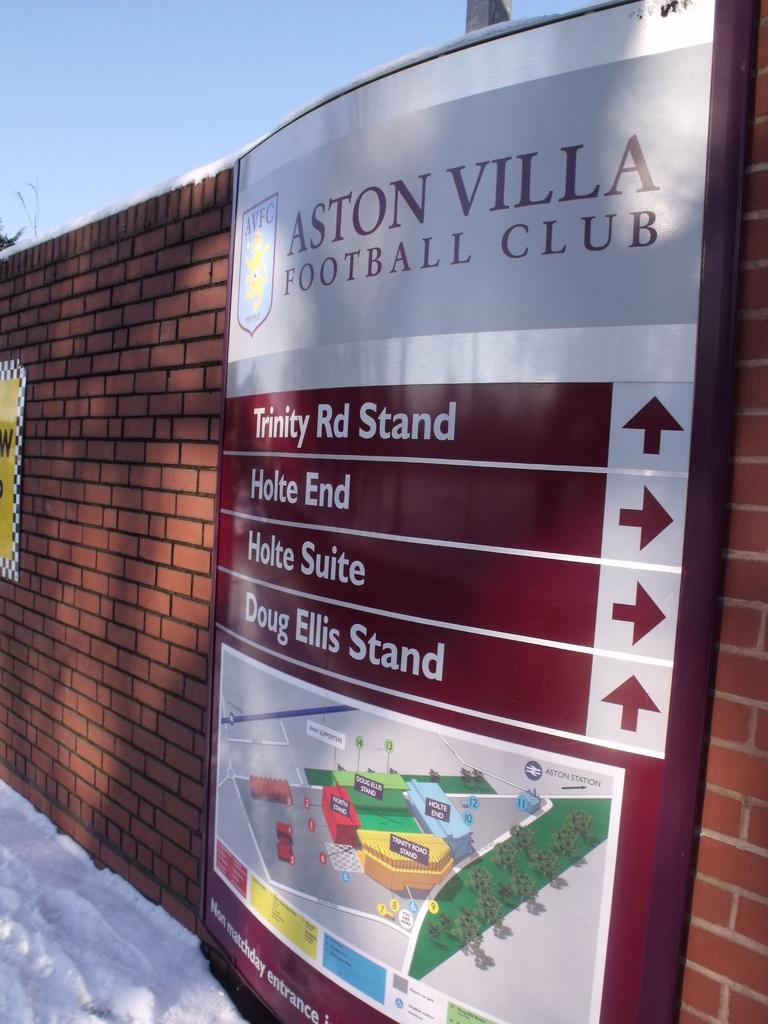What kind of club is this?
Your answer should be compact. Football. What is the name of the arrow pointing up?
Offer a very short reply. Trinity rd stand. 